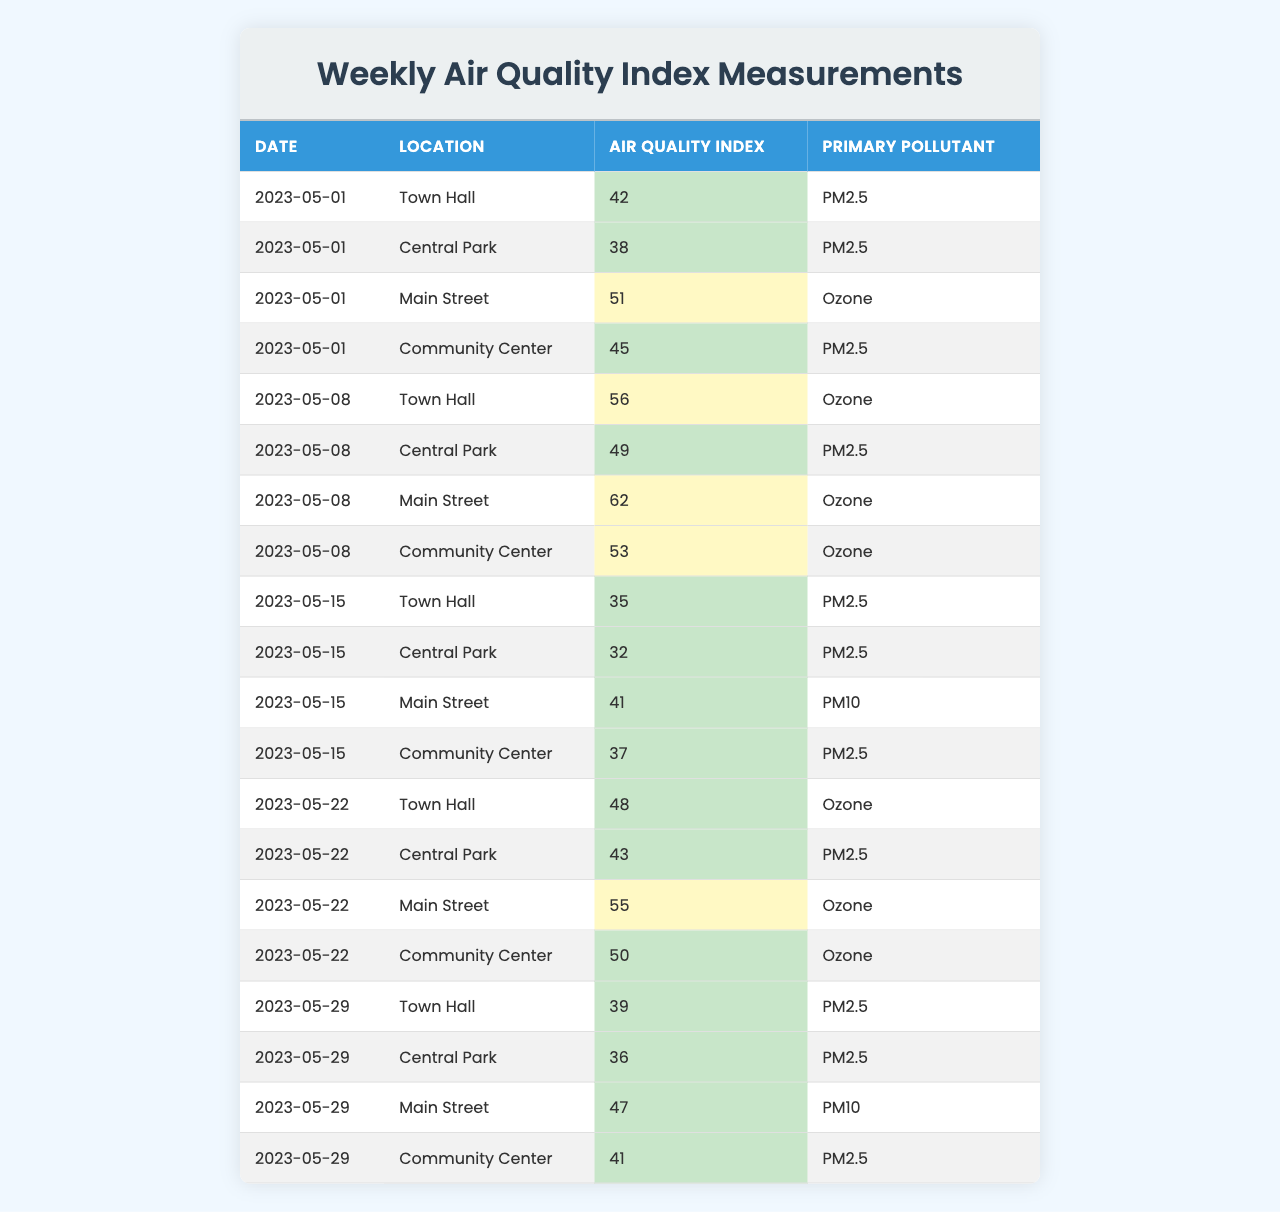What is the air quality index for Central Park on May 29, 2023? In the table, looking at the row for May 29, 2023, and the location Central Park, the air quality index value is 36.
Answer: 36 Which location had the highest air quality index on May 8, 2023? On May 8, 2023, comparing the air quality index values for Town Hall (56), Central Park (49), Main Street (62), and Community Center (53), Main Street has the highest value of 62.
Answer: Main Street Is the primary pollutant for the Town Hall on May 15, 2023 PM2.5? Checking the row for May 15, 2023, at Town Hall, the primary pollutant listed is PM2.5, which confirms that the statement is true.
Answer: Yes What was the average air quality index for the Community Center across all recorded weeks? To find the average, we add the air quality index values for the Community Center: 45 (May 1) + 53 (May 8) + 37 (May 15) + 50 (May 22) + 41 (May 29) = 226. There are five weeks, so we divide 226 by 5, resulting in an average air quality index of 45.2.
Answer: 45.2 On which dates did the Central Park record an air quality index above 40? The air quality index for Central Park recorded above 40 on May 8 (49), May 22 (43), and May 29 (36). Therefore, it was above 40 on May 8 and May 22.
Answer: May 8 and May 22 What is the total number of instances where Ozone was identified as the primary pollutant? Looking through the table, we count the occurrences of Ozone as the primary pollutant: it appears for Main Street on May 1, Town Hall on May 8, Main Street on May 8, Community Center on May 8, Town Hall on May 22, Main Street on May 22, and Community Center on May 22. This gives a total of 7 instances.
Answer: 7 Which week had the lowest air quality index overall? Checking the air quality index for each location across the weeks, the values for May 15 are Town Hall (35), Central Park (32), Main Street (41), Community Center (37) which sums up to 145. Comparing this with other weeks, May 15 has the lowest total air quality index.
Answer: May 15 Is the air quality index consistently below 50 during the week of May 15, 2023? For May 15, the recorded air quality indices are 35 (Town Hall), 32 (Central Park), 41 (Main Street), and 37 (Community Center). All values are below 50, confirming the statement as true.
Answer: Yes What was the difference in air quality index between Town Hall and Main Street on May 22, 2023? On May 22, the air quality index for Town Hall is 48 and for Main Street is 55. The difference is calculated as 55 - 48 = 7.
Answer: 7 